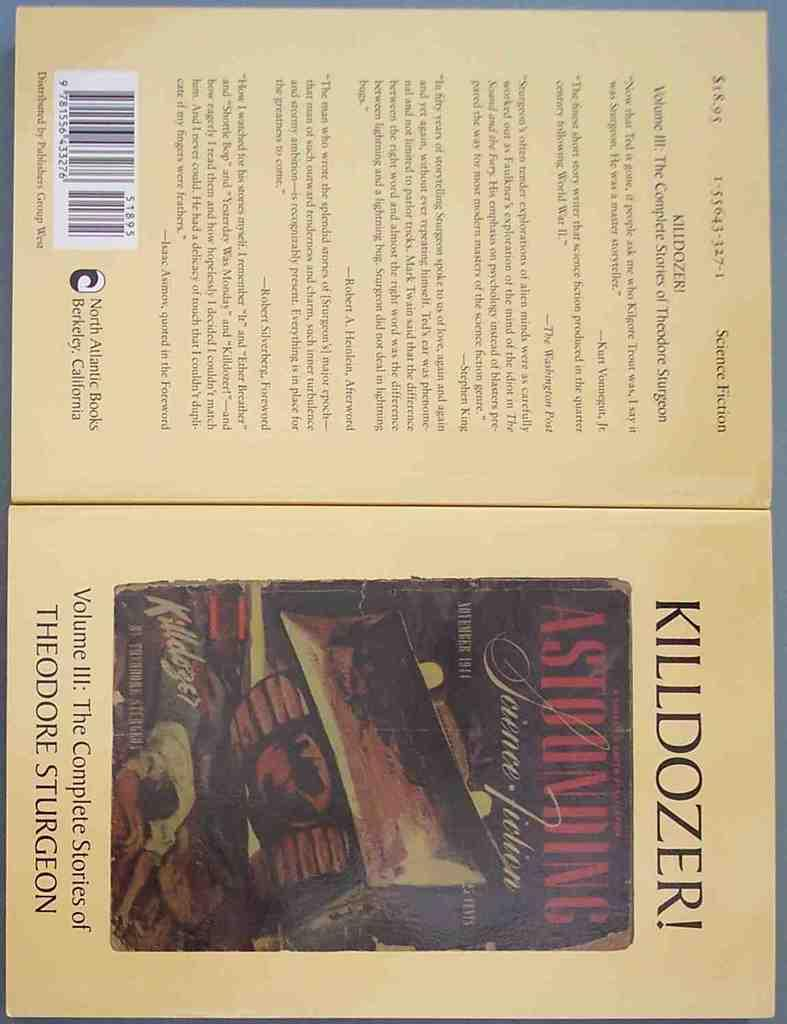<image>
Render a clear and concise summary of the photo. The boo is written by the author Theodore Sturgeon 